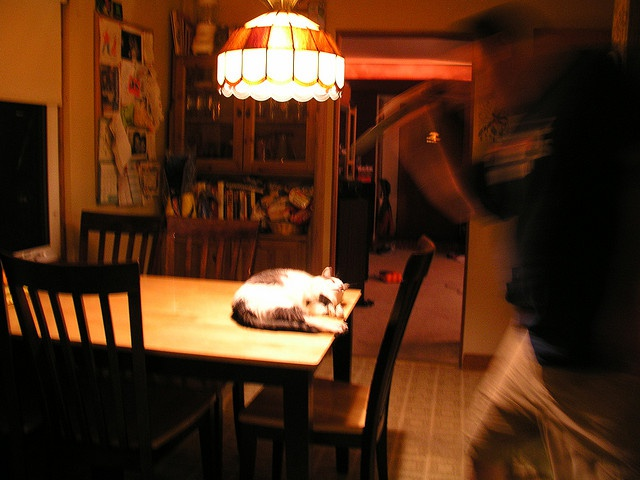Describe the objects in this image and their specific colors. I can see people in maroon, black, brown, and tan tones, chair in maroon, black, orange, and red tones, dining table in maroon, black, khaki, orange, and gold tones, chair in maroon, black, and brown tones, and tv in maroon, black, and brown tones in this image. 